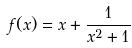<formula> <loc_0><loc_0><loc_500><loc_500>f ( x ) = x + \frac { 1 } { x ^ { 2 } + 1 }</formula> 